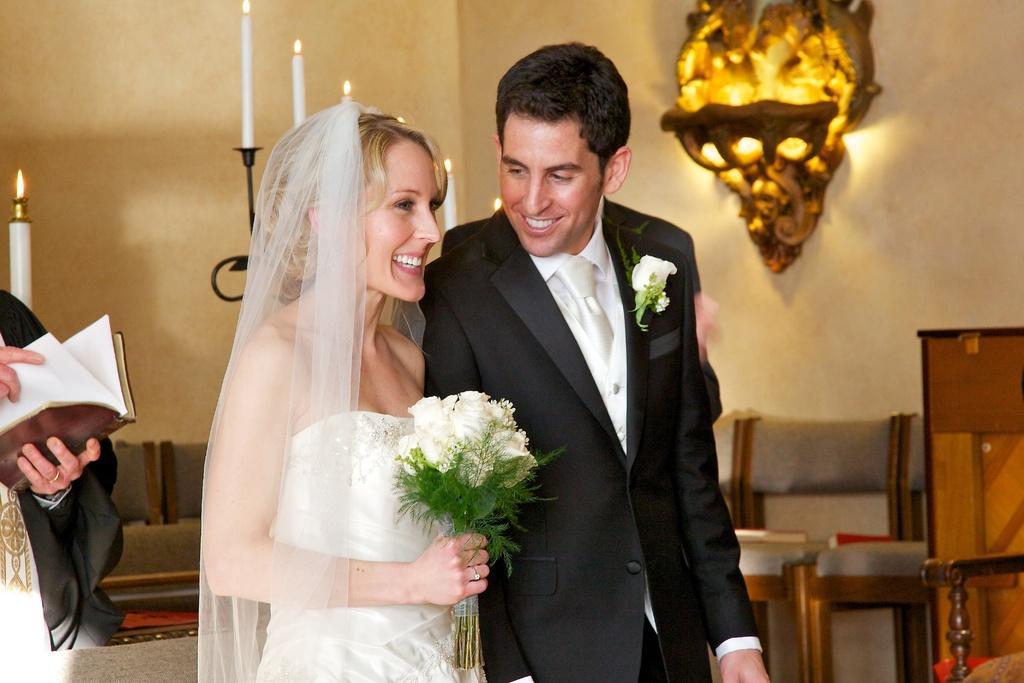How would you summarize this image in a sentence or two? In a room there is a bride and groom standing and smiling. The bride holding bunch of white flowers and behind them there are chairs and stand with candle on it. 